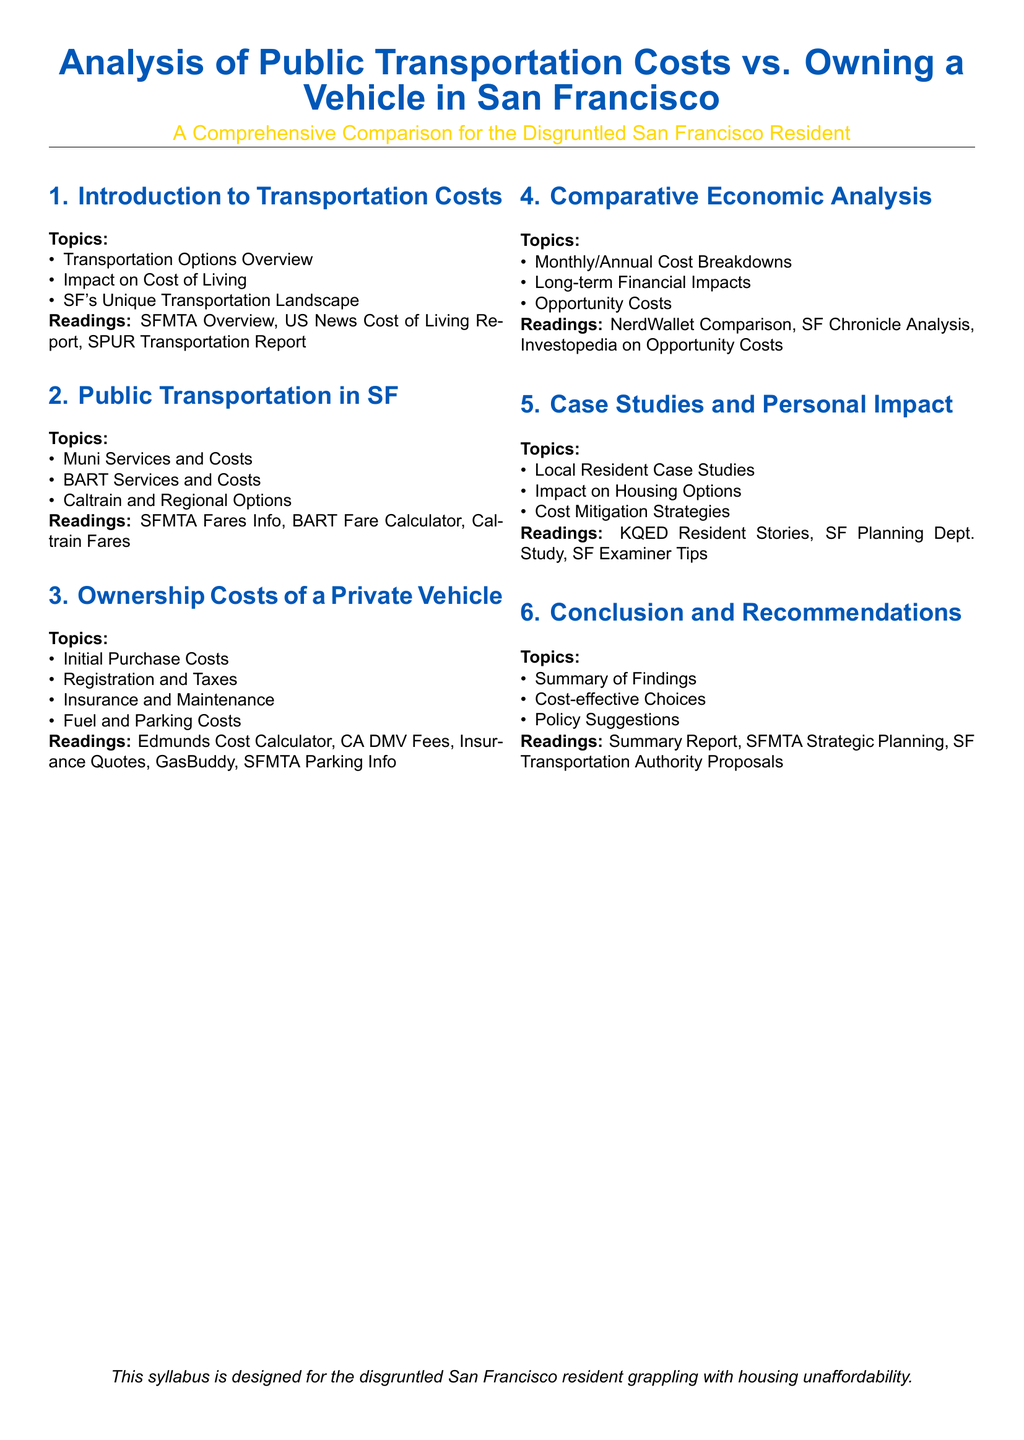What are the three main transportation options? The document lists transportation options that cover Muni, BART, and regional options like Caltrain.
Answer: Muni, BART, Caltrain What is the purpose of the syllabus? The syllabus is designed to provide a comprehensive comparison of transportation costs for those dealing with housing unaffordability in San Francisco.
Answer: Housing unaffordability What type of readings are included in Section 3? This section has readings focused on the costs associated with owning a vehicle, such as purchase costs, registration fees, and maintenance.
Answer: Edmunds Cost Calculator, CA DMV Fees, Insurance Quotes, GasBuddy, SFMTA Parking Info Which section discusses personal impact in transportation choices? This section evaluates local resident experiences and strategies for managing transportation costs in relation to housing.
Answer: Case Studies and Personal Impact What is one of the policy suggestions mentioned in the conclusion? The conclusion suggests exploring policy changes that could lead to more cost-effective transportation choices for residents.
Answer: Policy Suggestions 